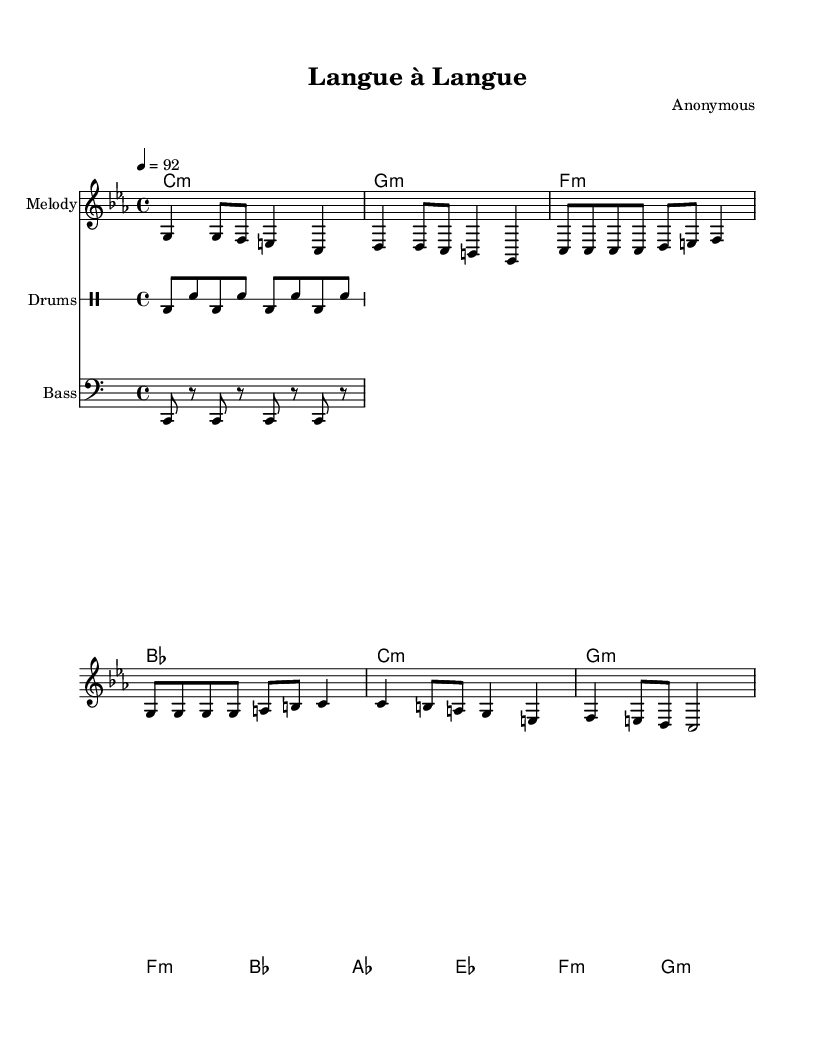What is the key signature of this music? The key signature shown at the beginning of the sheet music indicates C minor, which includes three flats (B♭, E♭, A♭).
Answer: C minor What is the time signature? The time signature written in the sheet music is 4/4, which means there are four beats in each measure.
Answer: 4/4 What is the tempo marking? The tempo marking in the music indicates a speed of 92 beats per minute, which suggests a moderately fast pace for the piece.
Answer: 92 How many measures are in the verse? By counting the measure bars in the verse section, it can be deduced that there are eight measures present.
Answer: 8 What type of percussion is used? The musical notation indicates the use of a standard drum setup with kick drum (bd) and snare (sn), which are common in hip hop music.
Answer: Drums How do the languages in the lyrics reflect the music's cultural context? The lyrics include both French and English, highlighting the bilingual nature of the rap and showcasing challenges in language learning through blending cultures.
Answer: Bilingual Which section follows the verse? After analyzing the structure of the music, it shows that the chorus section follows the verse based on its placement in the score.
Answer: Chorus 